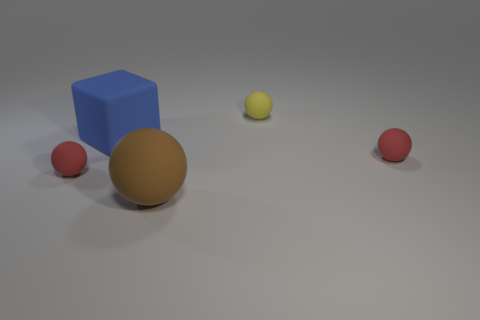Do the large blue rubber object and the large brown matte object have the same shape?
Provide a succinct answer. No. What size is the ball behind the red matte object that is behind the tiny red thing that is on the left side of the big blue block?
Your answer should be compact. Small. There is a thing behind the big blue cube; are there any large things that are on the right side of it?
Your answer should be very brief. No. What number of large blue matte objects are in front of the brown matte object in front of the red ball to the left of the yellow matte thing?
Keep it short and to the point. 0. The rubber sphere that is both to the right of the large matte cube and on the left side of the small yellow rubber object is what color?
Offer a very short reply. Brown. What number of small rubber spheres have the same color as the large matte block?
Ensure brevity in your answer.  0. What number of cylinders are either red matte objects or tiny matte things?
Your answer should be compact. 0. What is the color of the block that is the same size as the brown rubber ball?
Keep it short and to the point. Blue. Is there a big brown matte thing that is on the right side of the tiny red sphere that is left of the big object that is on the right side of the big blue cube?
Your answer should be very brief. Yes. What is the size of the matte block?
Offer a terse response. Large. 